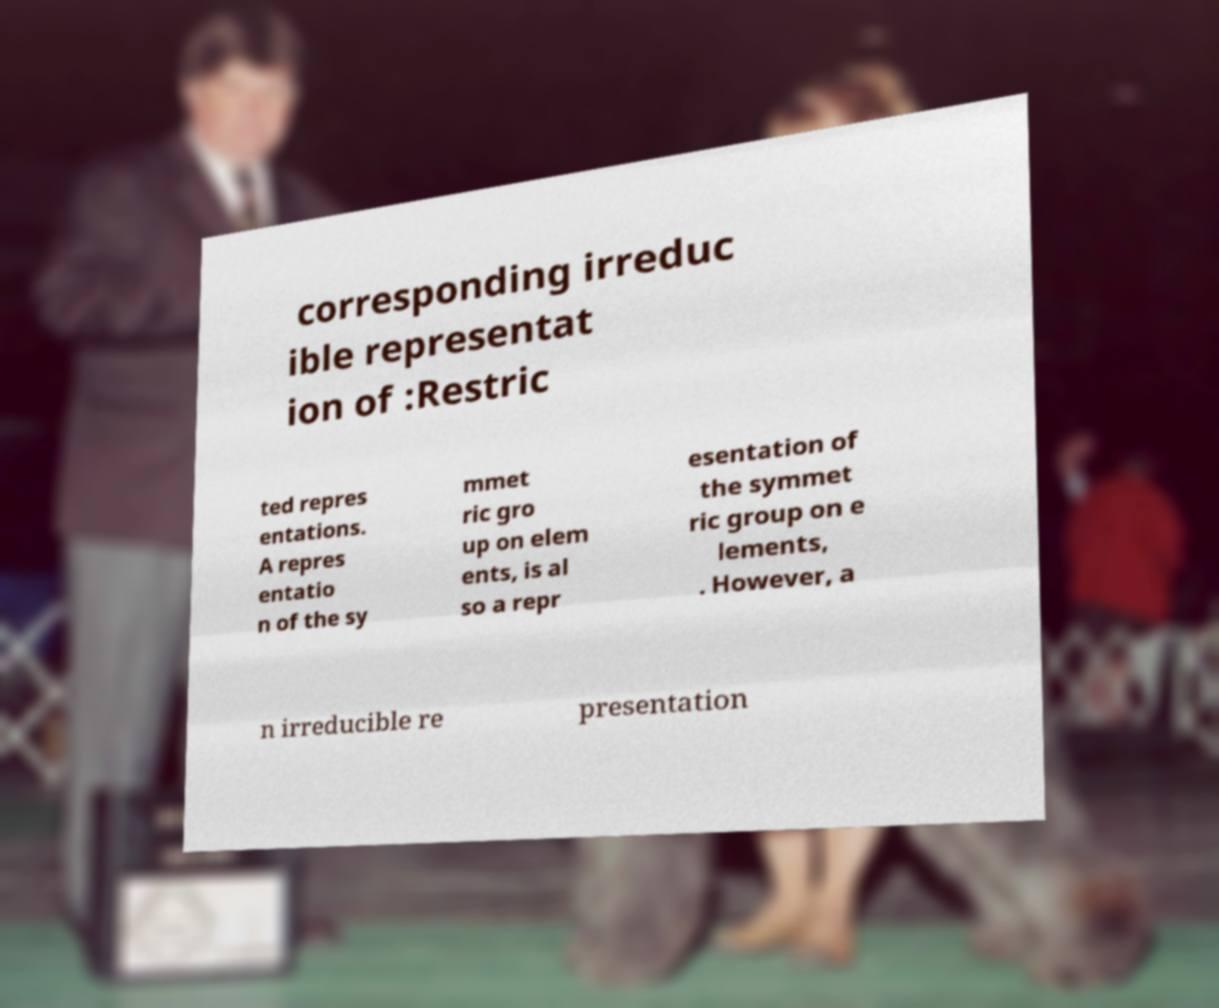There's text embedded in this image that I need extracted. Can you transcribe it verbatim? corresponding irreduc ible representat ion of :Restric ted repres entations. A repres entatio n of the sy mmet ric gro up on elem ents, is al so a repr esentation of the symmet ric group on e lements, . However, a n irreducible re presentation 